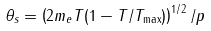Convert formula to latex. <formula><loc_0><loc_0><loc_500><loc_500>\theta _ { s } = \left ( 2 m _ { e } T ( 1 - T / T _ { \max } ) \right ) ^ { 1 / 2 } / p</formula> 